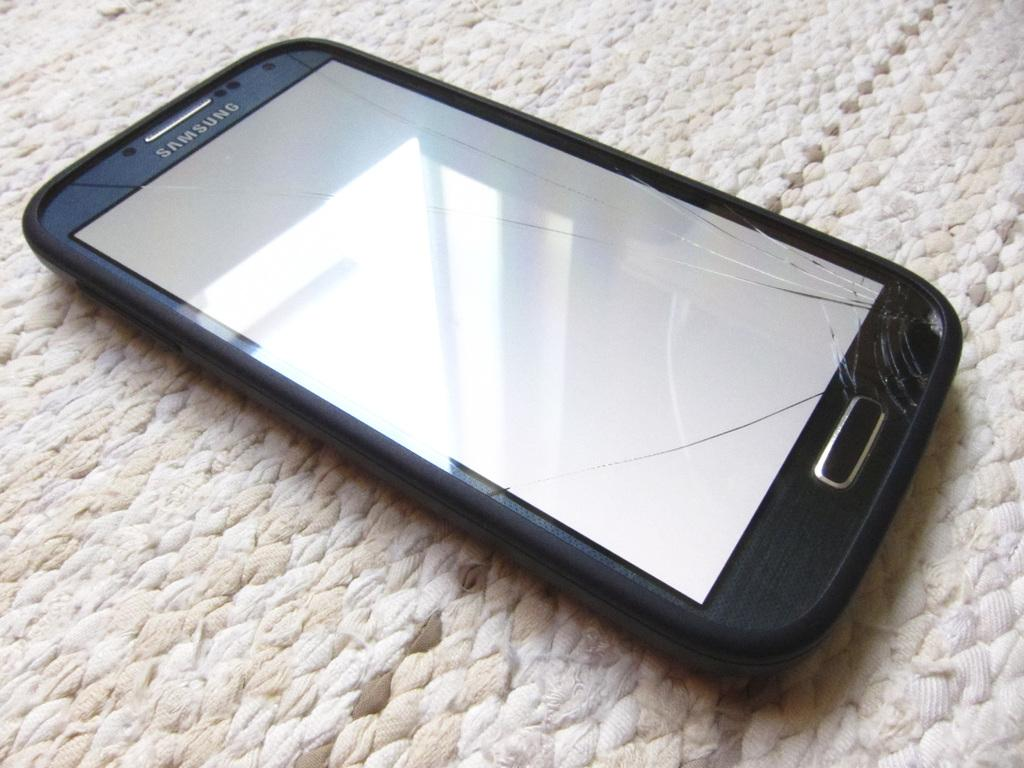Provide a one-sentence caption for the provided image. a cracked screen on a samsung smart phone. 